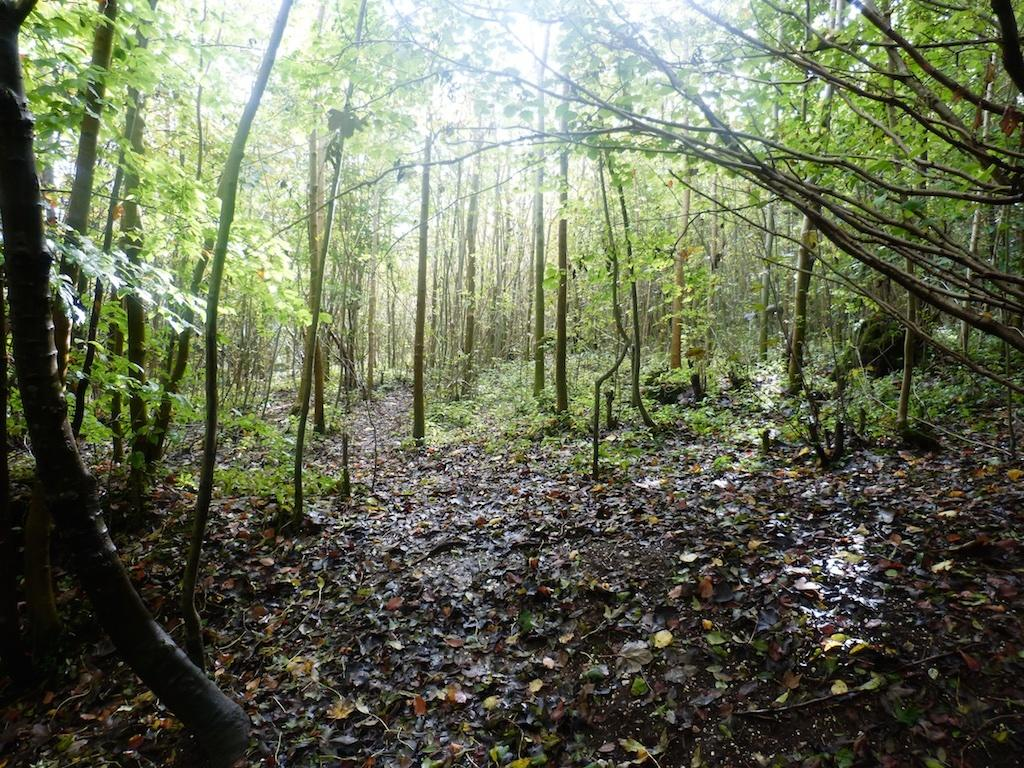What is present on the ground in the image? There are leaves and sticks on the ground in the image. What can be seen in the background of the image? There are trees visible in the background of the image. Is there a bath filled with sugar in the image? No, there is no bath or sugar present in the image. Can you see any wounds on the trees in the background? There is no mention of wounds in the image, and trees do not have the ability to experience wounds like living beings. 